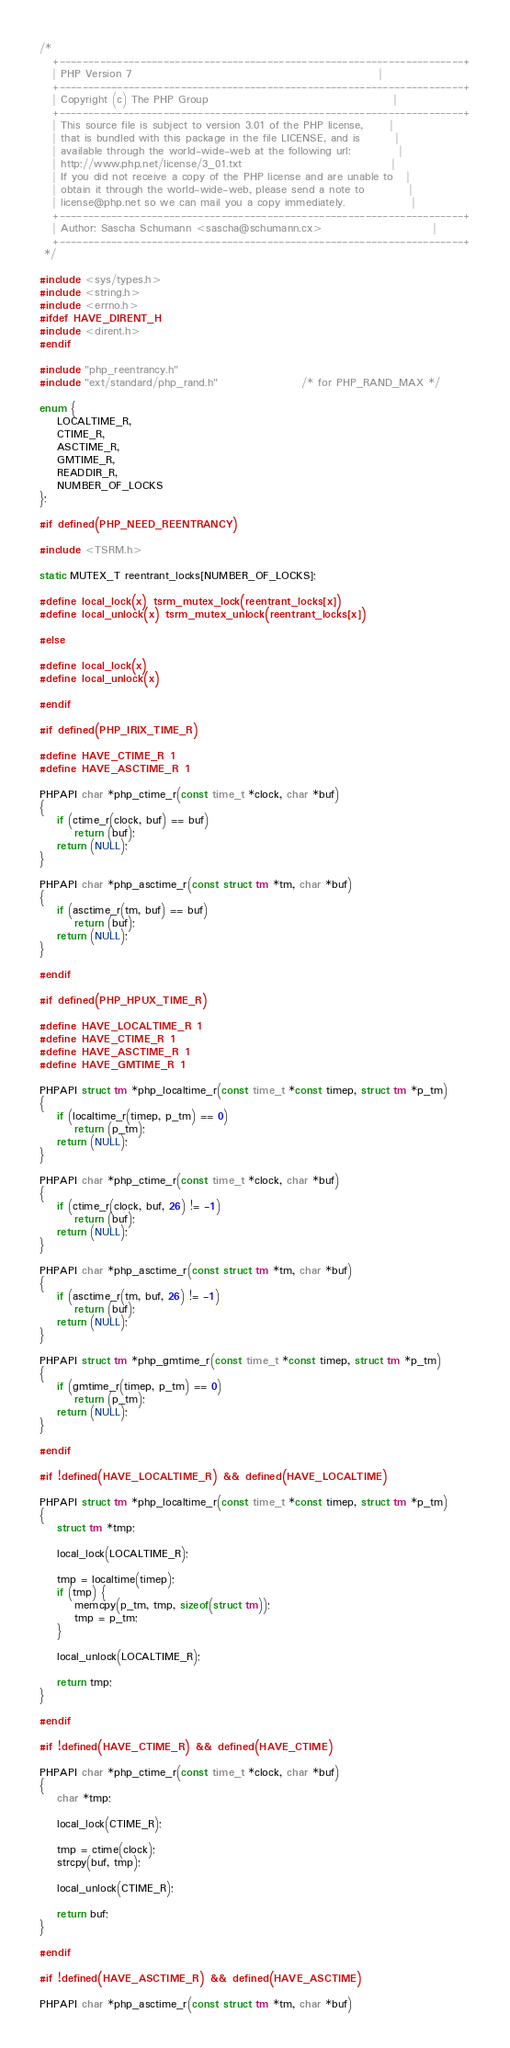Convert code to text. <code><loc_0><loc_0><loc_500><loc_500><_C_>/*
   +----------------------------------------------------------------------+
   | PHP Version 7                                                        |
   +----------------------------------------------------------------------+
   | Copyright (c) The PHP Group                                          |
   +----------------------------------------------------------------------+
   | This source file is subject to version 3.01 of the PHP license,      |
   | that is bundled with this package in the file LICENSE, and is        |
   | available through the world-wide-web at the following url:           |
   | http://www.php.net/license/3_01.txt                                  |
   | If you did not receive a copy of the PHP license and are unable to   |
   | obtain it through the world-wide-web, please send a note to          |
   | license@php.net so we can mail you a copy immediately.               |
   +----------------------------------------------------------------------+
   | Author: Sascha Schumann <sascha@schumann.cx>                         |
   +----------------------------------------------------------------------+
 */

#include <sys/types.h>
#include <string.h>
#include <errno.h>
#ifdef HAVE_DIRENT_H
#include <dirent.h>
#endif

#include "php_reentrancy.h"
#include "ext/standard/php_rand.h"                   /* for PHP_RAND_MAX */

enum {
	LOCALTIME_R,
	CTIME_R,
	ASCTIME_R,
	GMTIME_R,
	READDIR_R,
	NUMBER_OF_LOCKS
};

#if defined(PHP_NEED_REENTRANCY)

#include <TSRM.h>

static MUTEX_T reentrant_locks[NUMBER_OF_LOCKS];

#define local_lock(x) tsrm_mutex_lock(reentrant_locks[x])
#define local_unlock(x) tsrm_mutex_unlock(reentrant_locks[x])

#else

#define local_lock(x)
#define local_unlock(x)

#endif

#if defined(PHP_IRIX_TIME_R)

#define HAVE_CTIME_R 1
#define HAVE_ASCTIME_R 1

PHPAPI char *php_ctime_r(const time_t *clock, char *buf)
{
	if (ctime_r(clock, buf) == buf)
		return (buf);
	return (NULL);
}

PHPAPI char *php_asctime_r(const struct tm *tm, char *buf)
{
	if (asctime_r(tm, buf) == buf)
		return (buf);
	return (NULL);
}

#endif

#if defined(PHP_HPUX_TIME_R)

#define HAVE_LOCALTIME_R 1
#define HAVE_CTIME_R 1
#define HAVE_ASCTIME_R 1
#define HAVE_GMTIME_R 1

PHPAPI struct tm *php_localtime_r(const time_t *const timep, struct tm *p_tm)
{
	if (localtime_r(timep, p_tm) == 0)
		return (p_tm);
	return (NULL);
}

PHPAPI char *php_ctime_r(const time_t *clock, char *buf)
{
	if (ctime_r(clock, buf, 26) != -1)
		return (buf);
	return (NULL);
}

PHPAPI char *php_asctime_r(const struct tm *tm, char *buf)
{
	if (asctime_r(tm, buf, 26) != -1)
		return (buf);
	return (NULL);
}

PHPAPI struct tm *php_gmtime_r(const time_t *const timep, struct tm *p_tm)
{
	if (gmtime_r(timep, p_tm) == 0)
		return (p_tm);
	return (NULL);
}

#endif

#if !defined(HAVE_LOCALTIME_R) && defined(HAVE_LOCALTIME)

PHPAPI struct tm *php_localtime_r(const time_t *const timep, struct tm *p_tm)
{
	struct tm *tmp;

	local_lock(LOCALTIME_R);

	tmp = localtime(timep);
	if (tmp) {
		memcpy(p_tm, tmp, sizeof(struct tm));
		tmp = p_tm;
	}

	local_unlock(LOCALTIME_R);

	return tmp;
}

#endif

#if !defined(HAVE_CTIME_R) && defined(HAVE_CTIME)

PHPAPI char *php_ctime_r(const time_t *clock, char *buf)
{
	char *tmp;

	local_lock(CTIME_R);

	tmp = ctime(clock);
	strcpy(buf, tmp);

	local_unlock(CTIME_R);

	return buf;
}

#endif

#if !defined(HAVE_ASCTIME_R) && defined(HAVE_ASCTIME)

PHPAPI char *php_asctime_r(const struct tm *tm, char *buf)</code> 